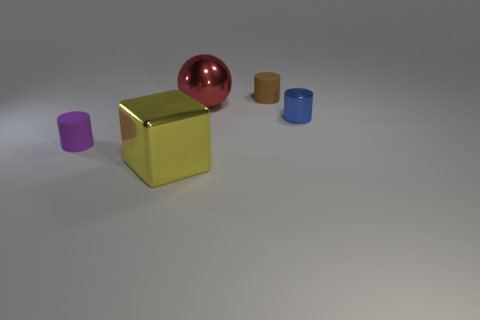Is the size of the rubber cylinder that is on the right side of the cube the same as the cube?
Your answer should be very brief. No. What is the large yellow thing that is right of the matte thing that is to the left of the rubber object behind the big metal sphere made of?
Your answer should be very brief. Metal. What material is the thing on the right side of the cylinder behind the small metal cylinder?
Offer a terse response. Metal. There is a ball that is the same size as the yellow thing; what color is it?
Ensure brevity in your answer.  Red. There is a purple rubber thing; is its shape the same as the small thing that is behind the tiny blue cylinder?
Offer a very short reply. Yes. What number of balls are to the left of the tiny thing left of the matte cylinder to the right of the purple rubber cylinder?
Your answer should be compact. 0. What size is the thing behind the metal object that is behind the blue cylinder?
Offer a very short reply. Small. What is the size of the yellow block that is the same material as the big red sphere?
Your response must be concise. Large. There is a thing that is both in front of the small shiny thing and on the right side of the tiny purple thing; what shape is it?
Offer a very short reply. Cube. Are there the same number of tiny rubber cylinders in front of the small purple matte thing and tiny yellow matte balls?
Provide a short and direct response. Yes. 